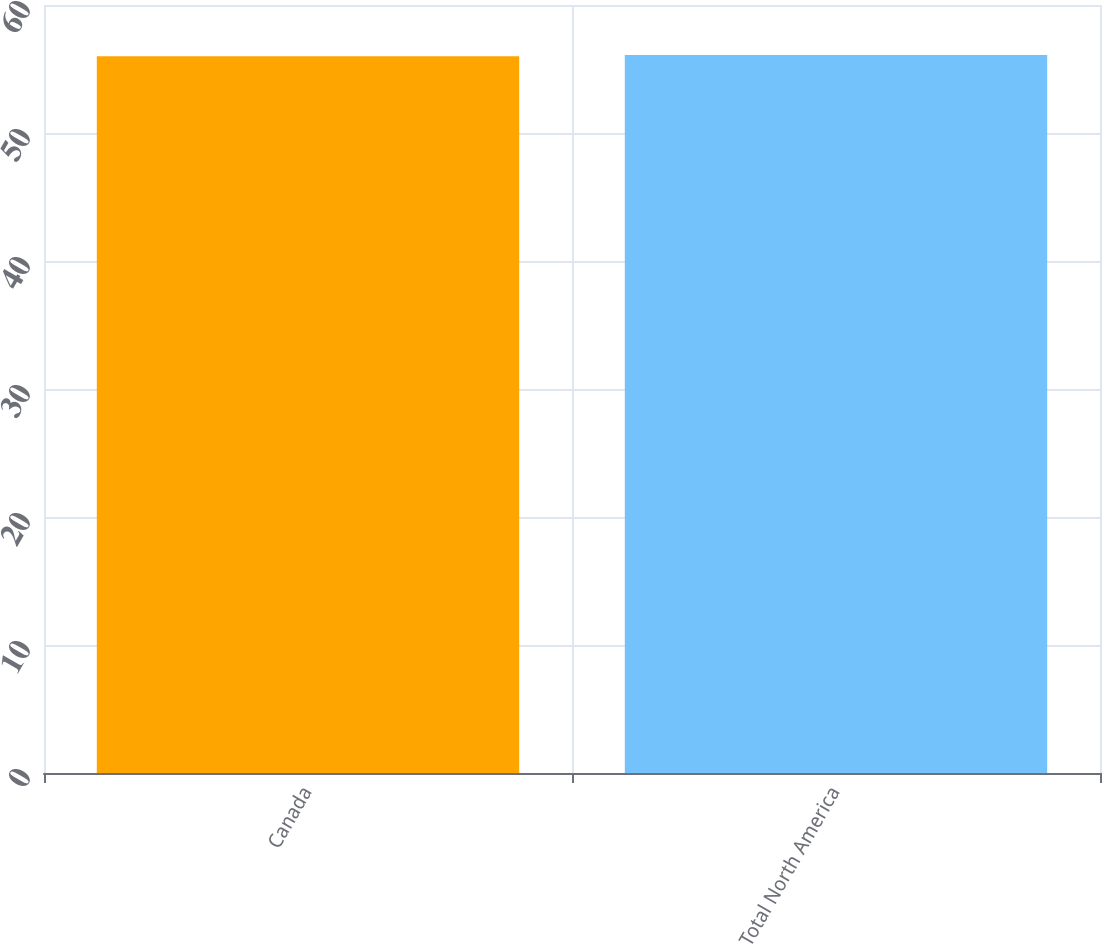Convert chart. <chart><loc_0><loc_0><loc_500><loc_500><bar_chart><fcel>Canada<fcel>Total North America<nl><fcel>56<fcel>56.1<nl></chart> 